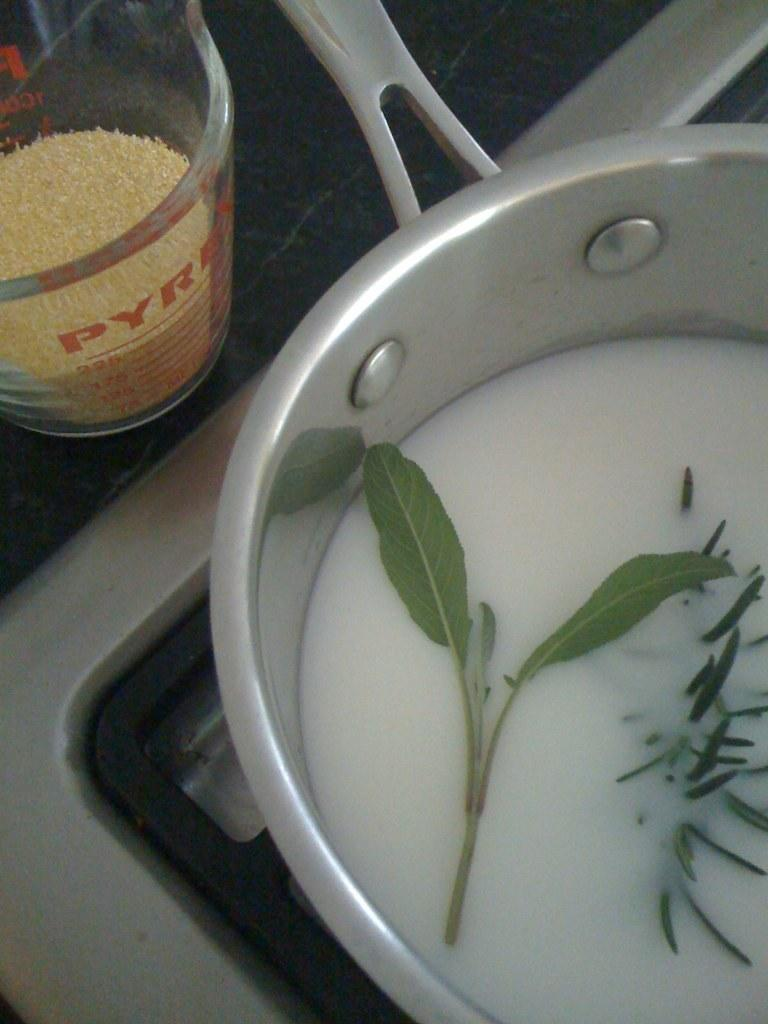What is in the bowl that is visible in the image? There is a bowl with liquid and leaves in the image. What can be seen on the left side of the image? There is a glass with an item in it on the left side of the image. What flavor of beef is being prepared in the image? There is no beef present in the image, and therefore no flavor can be determined. 